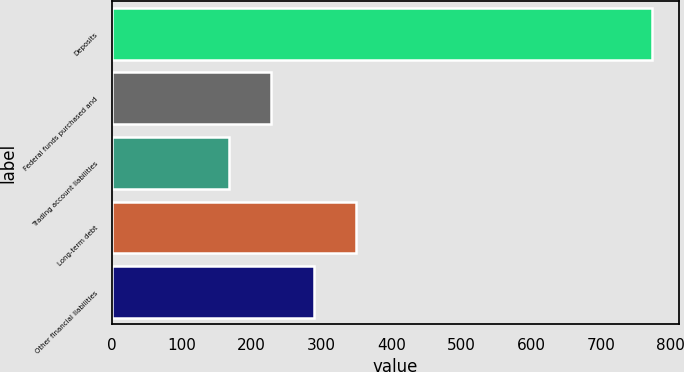Convert chart. <chart><loc_0><loc_0><loc_500><loc_500><bar_chart><fcel>Deposits<fcel>Federal funds purchased and<fcel>Trading account liabilities<fcel>Long-term debt<fcel>Other financial liabilities<nl><fcel>772.9<fcel>228.04<fcel>167.5<fcel>349.12<fcel>288.58<nl></chart> 